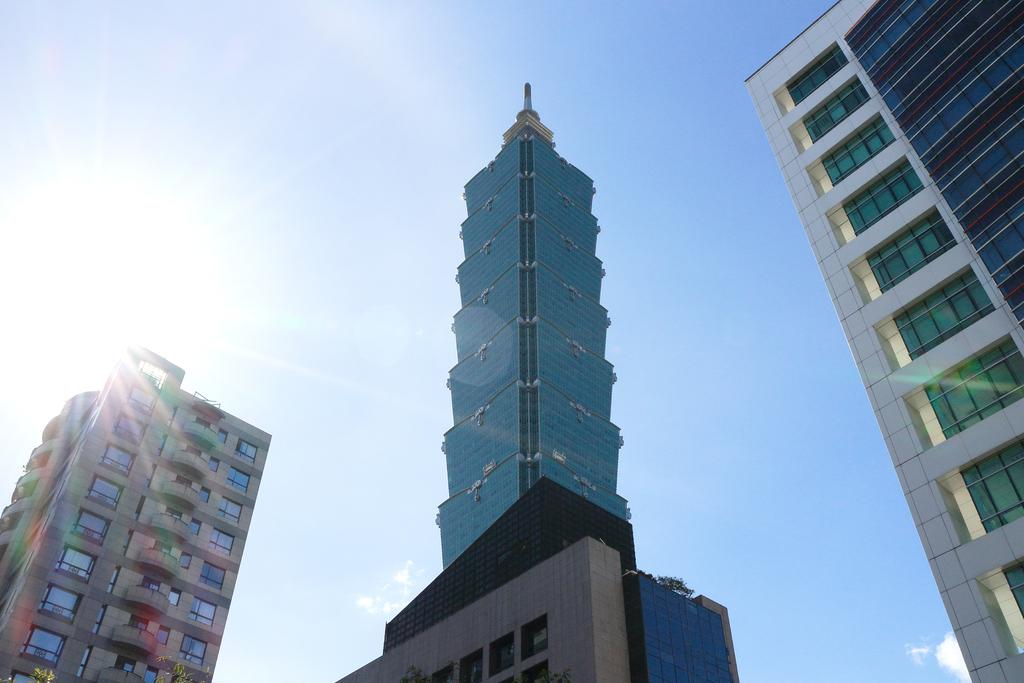What type of structures are present in the image? There are buildings with windows in the image. What can be seen in the background of the image? The sky is visible in the background of the image. Are there any fairies visible on the edge of the buildings in the image? There are no fairies present in the image, and the buildings do not have an edge as they are depicted in a two-dimensional manner. 